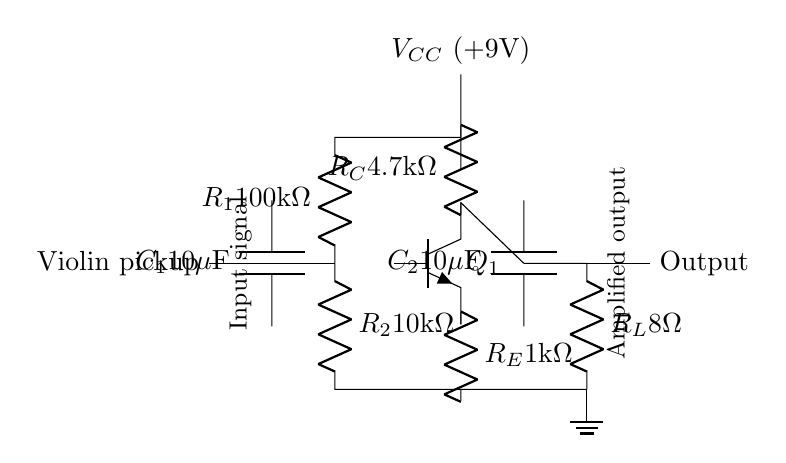What is the value of capacitor C1? The circuit shows C1 is labeled with a value of 10 microfarads, denoted as 10μF.
Answer: 10 microfarads What type of transistor is used in this circuit? The transistor is labeled as Q1 with a symbol indicating it is an NPN type, as seen from its configuration in the circuit.
Answer: NPN What is the resistance of R2? In the circuit, R2 is marked with a value of 10 kilohms, which indicates its resistance.
Answer: 10 kilohms What is the purpose of capacitor C2? C2 is connected to the output of the amplifier and is used for coupling the output, allowing AC signals to pass while blocking DC.
Answer: Coupling What is the total current flowing through R_E? To determine the total current, it is necessary to apply Kirchhoff's current law and calculate the base current, collector current, and emitter current, but the specific value is not provided in the circuit diagram.
Answer: Not specified What is the voltage supply value for V_CC? The diagram shows V_CC as labeled 9 volts, indicating the supply voltage for the circuit.
Answer: 9 volts What type of output load is indicated by R_L? The load R_L is indicated with a value of 8 ohms, which suggests that it is a typical load for audio applications such as a speaker.
Answer: 8 ohms 